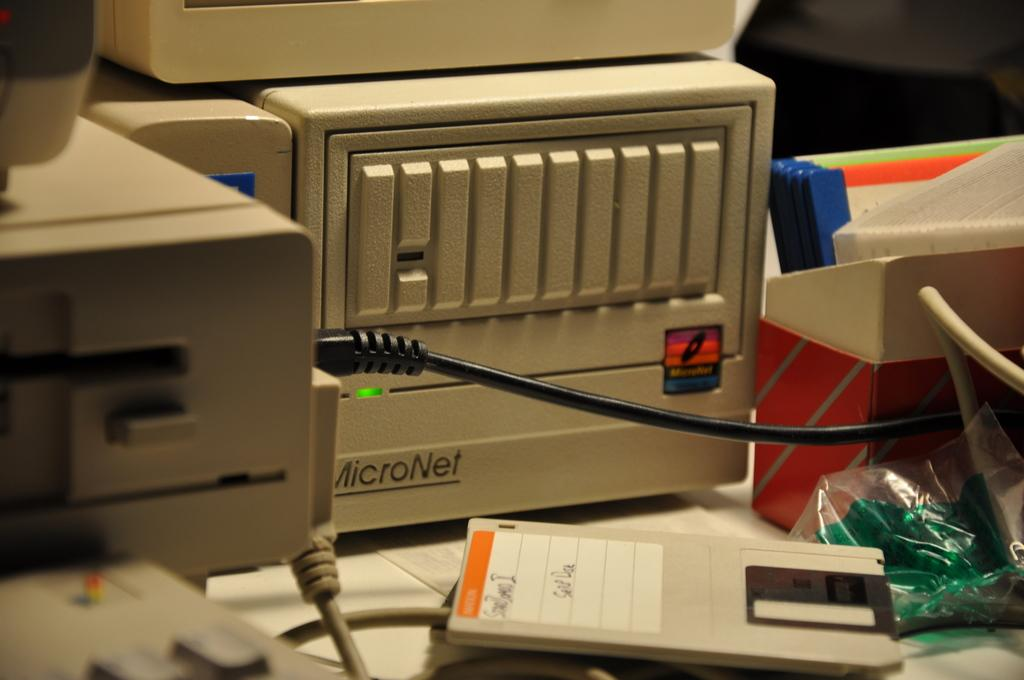<image>
Offer a succinct explanation of the picture presented. An old MicroNet computer is plugged in and operating. 